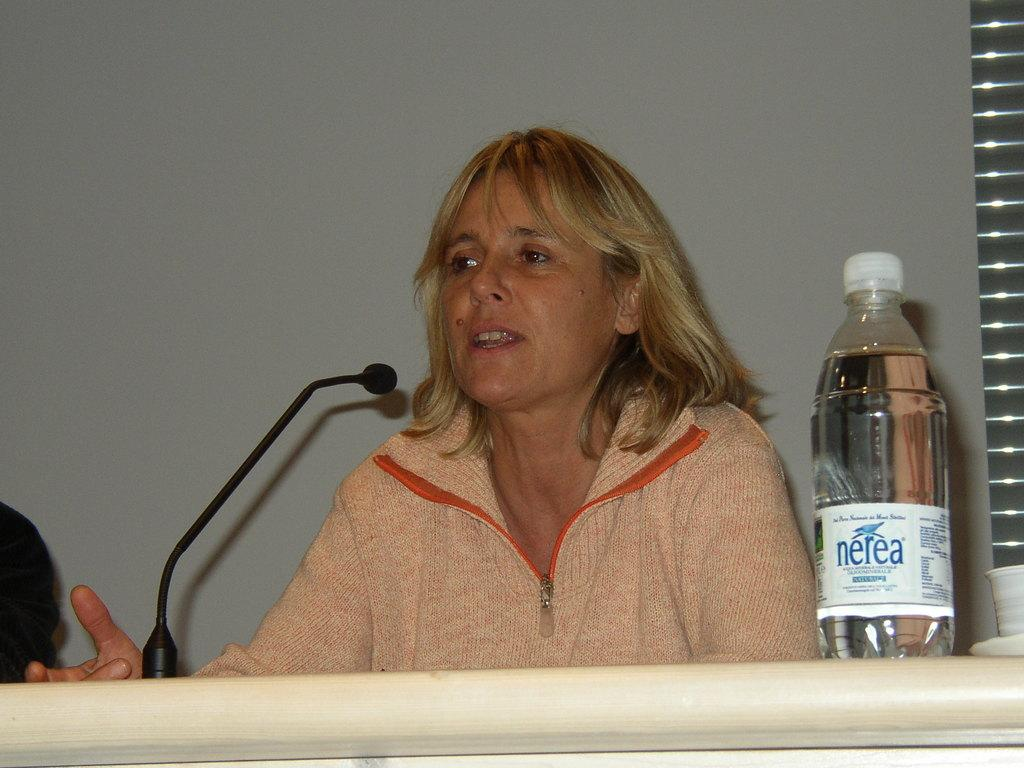What is the main subject of the image? The main subject of the image is a woman. What is the woman doing in the image? The woman is sitting in front of a table and speaking into a microphone. What can be seen on the table in the image? There is a bottle on the table. What type of elbow can be seen on the woman's arm in the image? There is no visible elbow on the woman's arm in the image. What type of argument is the woman making into the microphone in the image? There is no indication of an argument in the image; the woman is simply speaking into the microphone. 